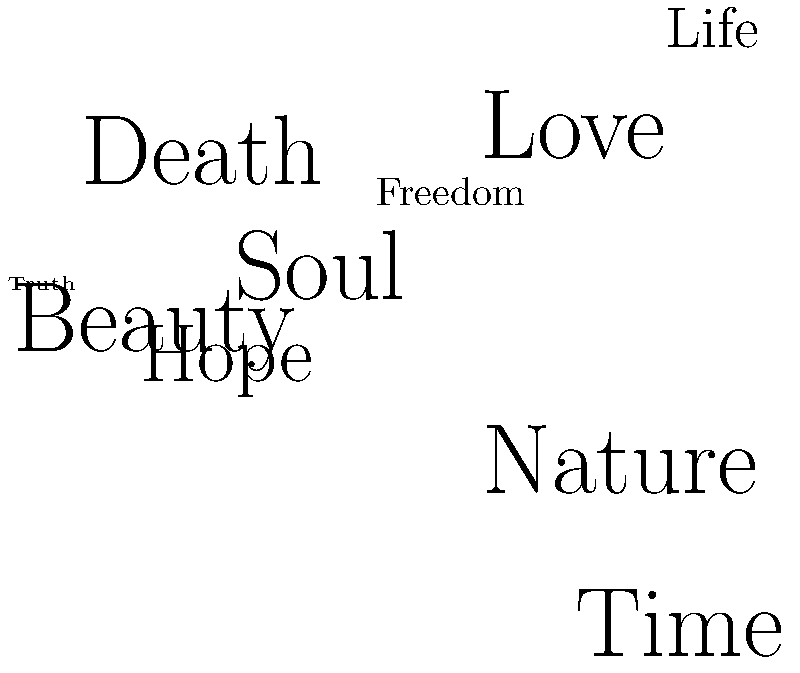Based on the word cloud presented, which prominent Romantic poet's work is most likely being represented, and what major theme can be inferred from the most prominent words? To answer this question, we need to analyze the word cloud and follow these steps:

1. Identify the most prominent words: The largest words in the cloud are "Nature," "Love," "Time," and "Death."

2. Consider the Romantic period in literature: This movement emphasized emotions, individualism, and the beauty of nature.

3. Analyze the combination of themes:
   - Nature: A central theme in Romantic poetry
   - Love: A common subject in lyrical poetry
   - Time and Death: Often explored in philosophical reflections

4. Recall prominent Romantic poets:
   - William Wordsworth: Known for nature poetry
   - Lord Byron: Often wrote about love and passion
   - Percy Bysshe Shelley: Explored themes of nature and philosophy
   - John Keats: Frequently addressed themes of beauty, nature, and mortality

5. Consider the overall balance of themes: The presence of both nature and more abstract concepts like time, death, and soul suggests a poet who blended tangible and intangible elements.

6. Conclusion: Given the prominence of "Nature" and the philosophical undertones, the word cloud most likely represents the work of William Wordsworth.

7. Infer the major theme: The most prominent word is "Nature," indicating that this is the central theme in the represented works.
Answer: William Wordsworth; Nature as a central theme in Romantic poetry 